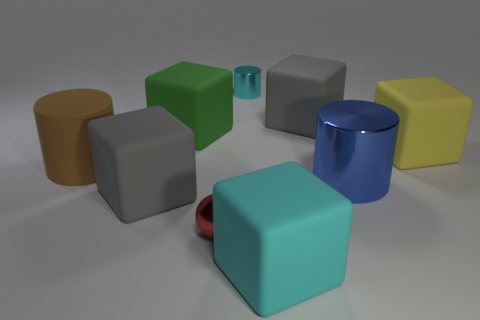Can you describe the arrangement of shapes in the image? The image shows a collection of geometric shapes arranged without a specific pattern on a flat surface. There are cylinders, cubes, and one cuboid distributed across the scene with varying colors and materials, including shiny and matte finishes. 